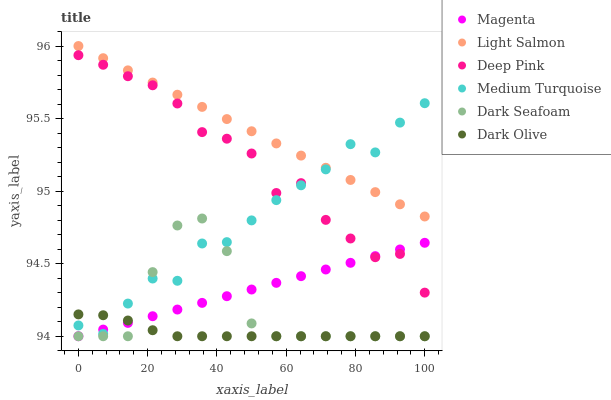Does Dark Olive have the minimum area under the curve?
Answer yes or no. Yes. Does Light Salmon have the maximum area under the curve?
Answer yes or no. Yes. Does Deep Pink have the minimum area under the curve?
Answer yes or no. No. Does Deep Pink have the maximum area under the curve?
Answer yes or no. No. Is Light Salmon the smoothest?
Answer yes or no. Yes. Is Dark Seafoam the roughest?
Answer yes or no. Yes. Is Deep Pink the smoothest?
Answer yes or no. No. Is Deep Pink the roughest?
Answer yes or no. No. Does Dark Olive have the lowest value?
Answer yes or no. Yes. Does Deep Pink have the lowest value?
Answer yes or no. No. Does Light Salmon have the highest value?
Answer yes or no. Yes. Does Deep Pink have the highest value?
Answer yes or no. No. Is Dark Seafoam less than Light Salmon?
Answer yes or no. Yes. Is Light Salmon greater than Dark Olive?
Answer yes or no. Yes. Does Medium Turquoise intersect Deep Pink?
Answer yes or no. Yes. Is Medium Turquoise less than Deep Pink?
Answer yes or no. No. Is Medium Turquoise greater than Deep Pink?
Answer yes or no. No. Does Dark Seafoam intersect Light Salmon?
Answer yes or no. No. 